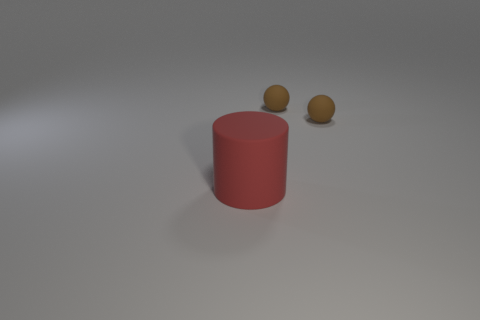Is the number of red cylinders less than the number of brown rubber things?
Provide a short and direct response. Yes. Are there any other things that have the same size as the cylinder?
Give a very brief answer. No. Is there a big rubber cylinder?
Give a very brief answer. Yes. What is the shape of the large red object?
Your response must be concise. Cylinder. How many objects are brown rubber balls or tiny green shiny balls?
Your response must be concise. 2. Are there any other tiny things that have the same material as the red thing?
Ensure brevity in your answer.  Yes. The red object has what size?
Ensure brevity in your answer.  Large. What number of tiny objects are red matte things or brown balls?
Make the answer very short. 2. There is a big red cylinder; what number of tiny brown matte spheres are to the left of it?
Your answer should be very brief. 0. How many blocks are tiny brown things or red rubber objects?
Provide a short and direct response. 0. 